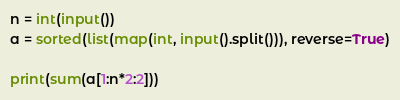Convert code to text. <code><loc_0><loc_0><loc_500><loc_500><_Python_>n = int(input())
a = sorted(list(map(int, input().split())), reverse=True)

print(sum(a[1:n*2:2]))</code> 